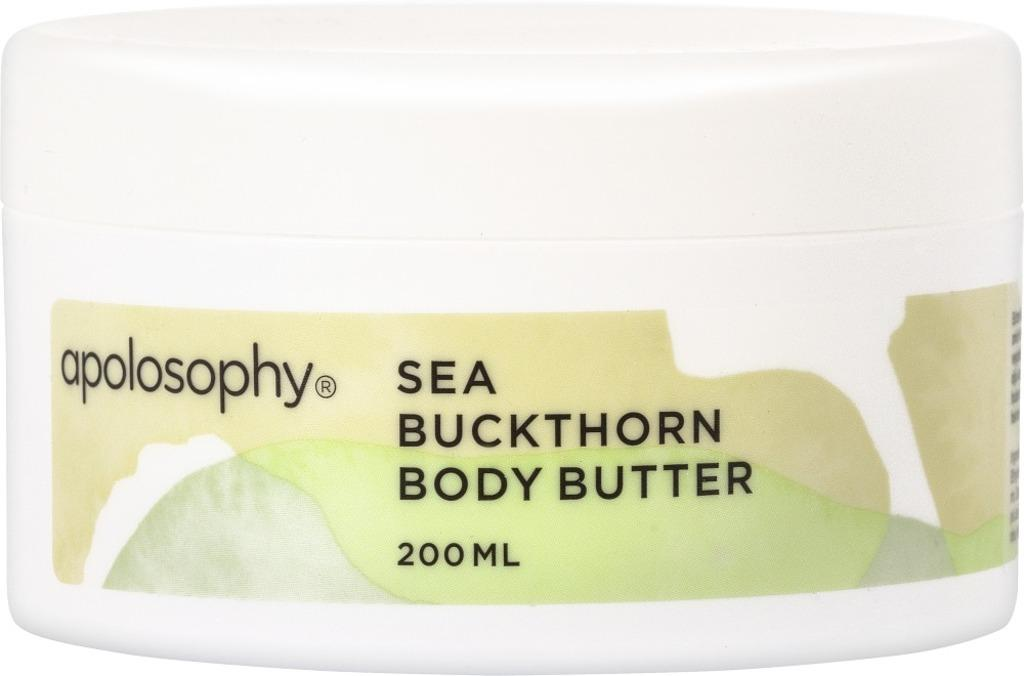<image>
Relay a brief, clear account of the picture shown. A white 200 ML container of apolosohy body butter. 